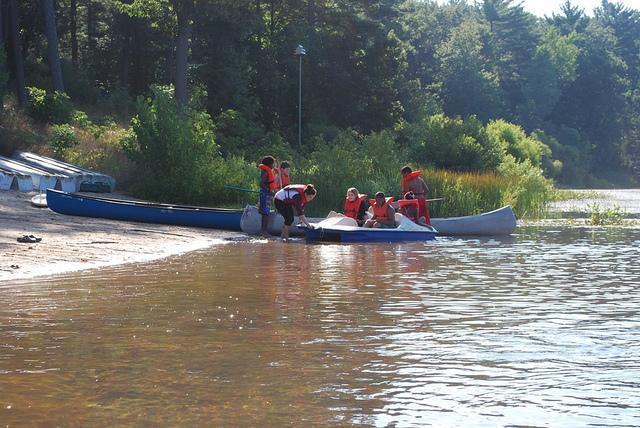How many boats are there?
Give a very brief answer. 2. 